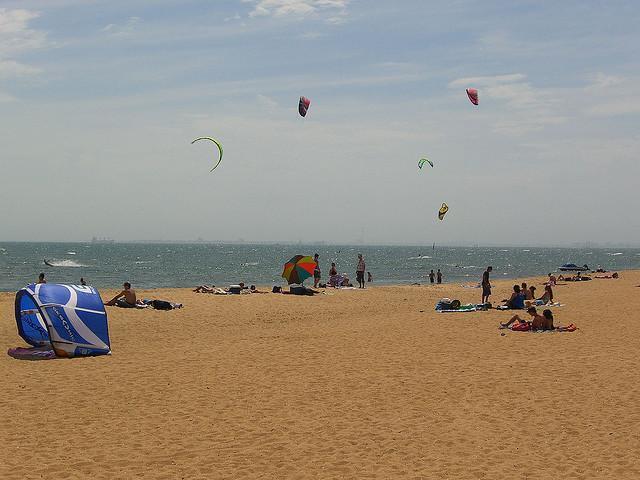What caused all the indents in the sand?
Make your selection from the four choices given to correctly answer the question.
Options: Foot traffic, acid rain, artillery fire, hail. Foot traffic. 